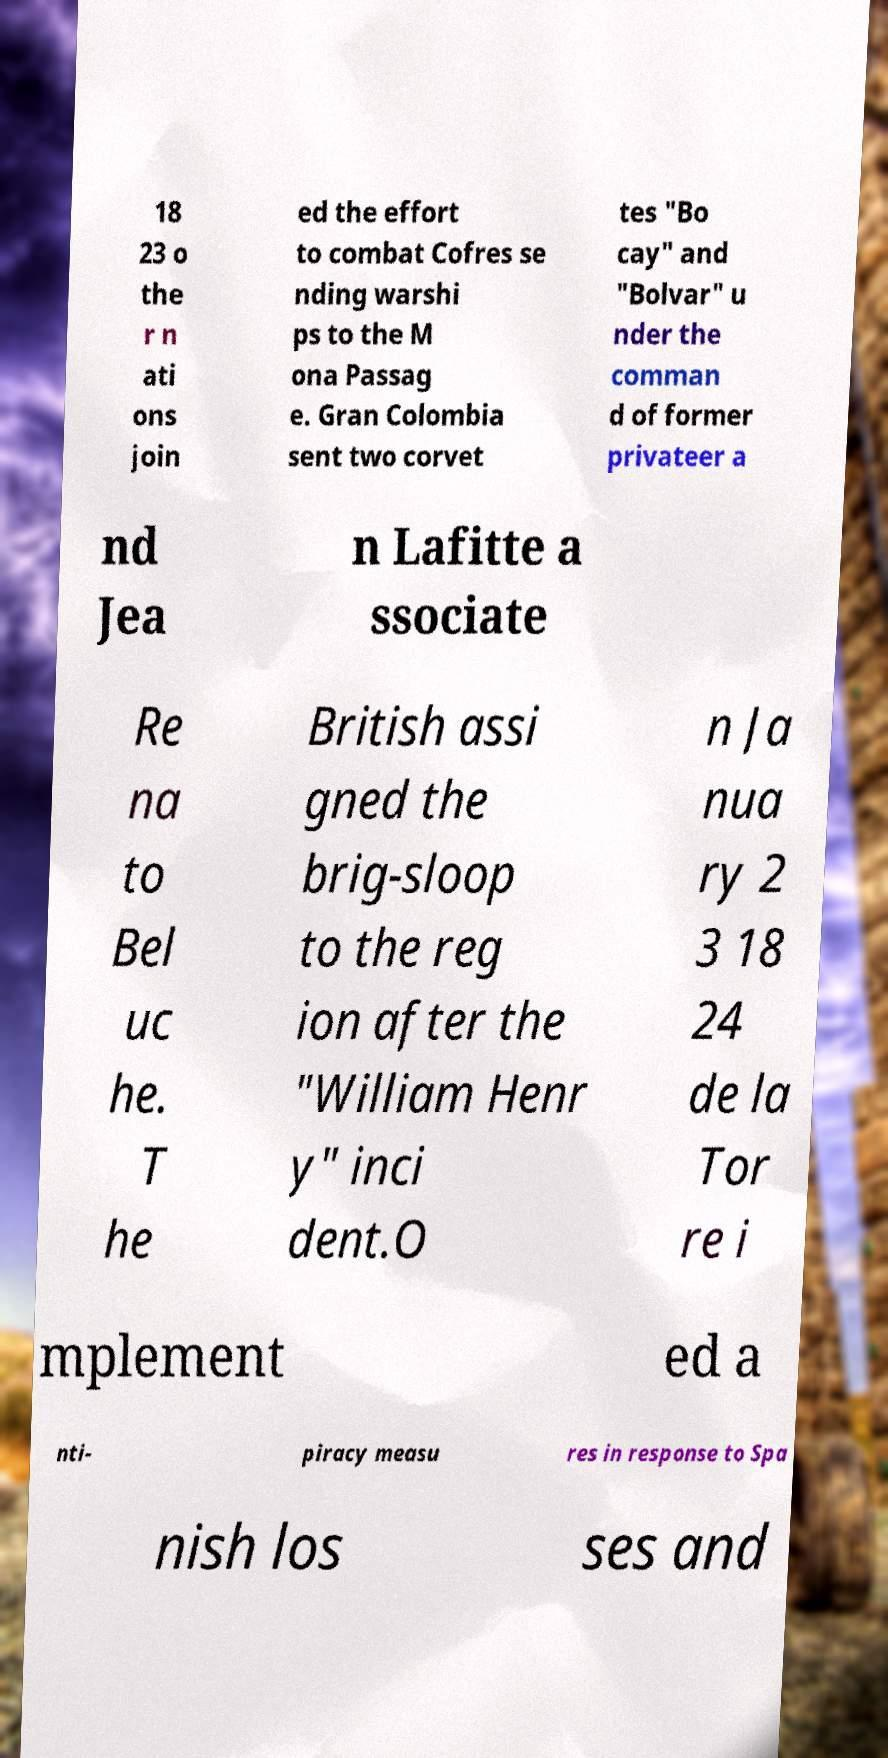Please identify and transcribe the text found in this image. 18 23 o the r n ati ons join ed the effort to combat Cofres se nding warshi ps to the M ona Passag e. Gran Colombia sent two corvet tes "Bo cay" and "Bolvar" u nder the comman d of former privateer a nd Jea n Lafitte a ssociate Re na to Bel uc he. T he British assi gned the brig-sloop to the reg ion after the "William Henr y" inci dent.O n Ja nua ry 2 3 18 24 de la Tor re i mplement ed a nti- piracy measu res in response to Spa nish los ses and 